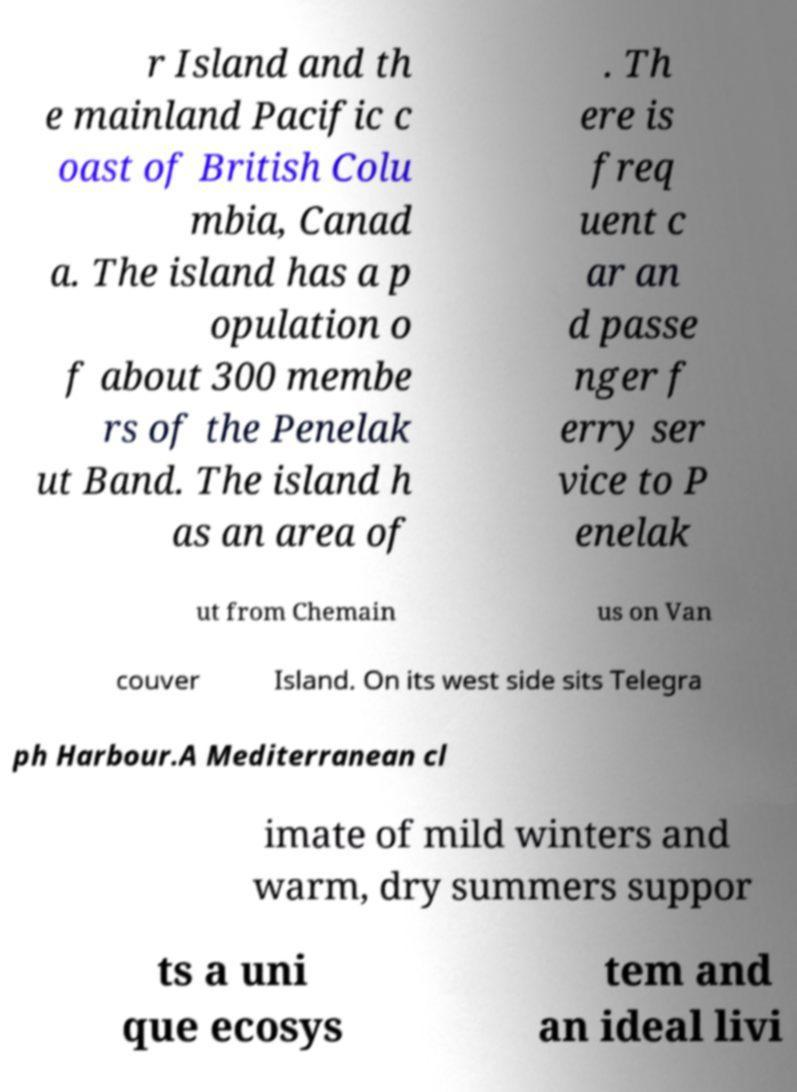Can you read and provide the text displayed in the image?This photo seems to have some interesting text. Can you extract and type it out for me? r Island and th e mainland Pacific c oast of British Colu mbia, Canad a. The island has a p opulation o f about 300 membe rs of the Penelak ut Band. The island h as an area of . Th ere is freq uent c ar an d passe nger f erry ser vice to P enelak ut from Chemain us on Van couver Island. On its west side sits Telegra ph Harbour.A Mediterranean cl imate of mild winters and warm, dry summers suppor ts a uni que ecosys tem and an ideal livi 